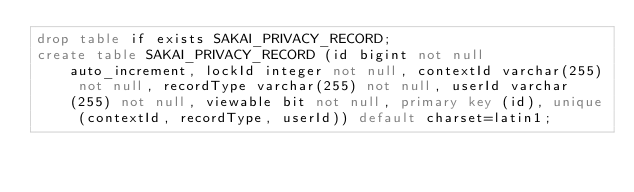<code> <loc_0><loc_0><loc_500><loc_500><_SQL_>drop table if exists SAKAI_PRIVACY_RECORD;
create table SAKAI_PRIVACY_RECORD (id bigint not null auto_increment, lockId integer not null, contextId varchar(255) not null, recordType varchar(255) not null, userId varchar(255) not null, viewable bit not null, primary key (id), unique (contextId, recordType, userId)) default charset=latin1;
</code> 